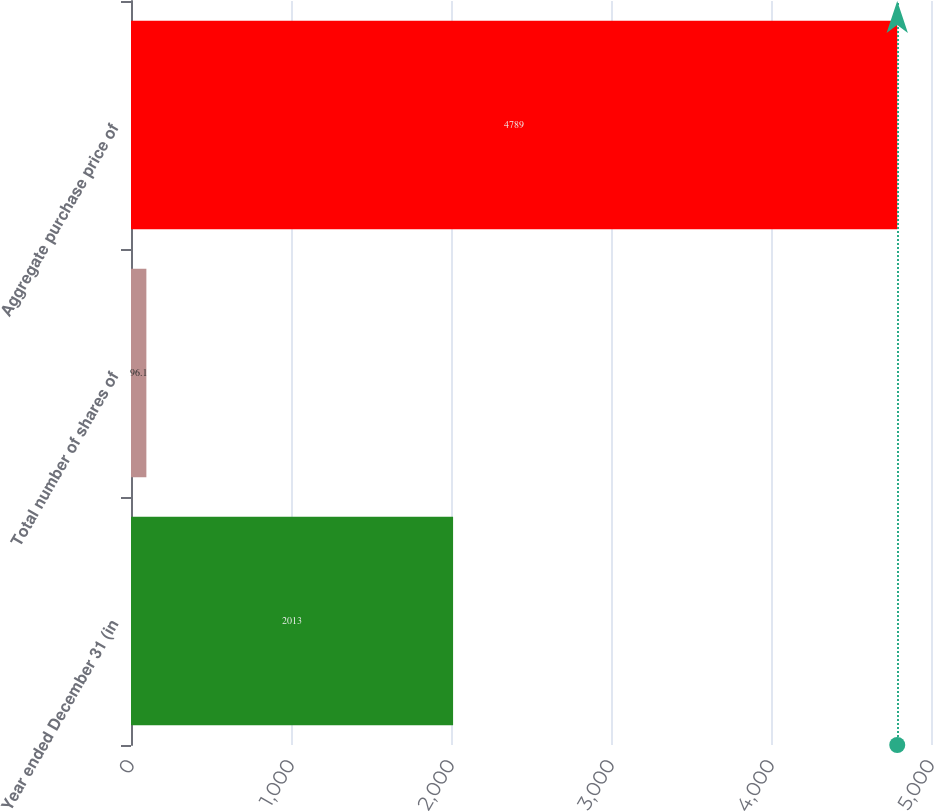Convert chart to OTSL. <chart><loc_0><loc_0><loc_500><loc_500><bar_chart><fcel>Year ended December 31 (in<fcel>Total number of shares of<fcel>Aggregate purchase price of<nl><fcel>2013<fcel>96.1<fcel>4789<nl></chart> 